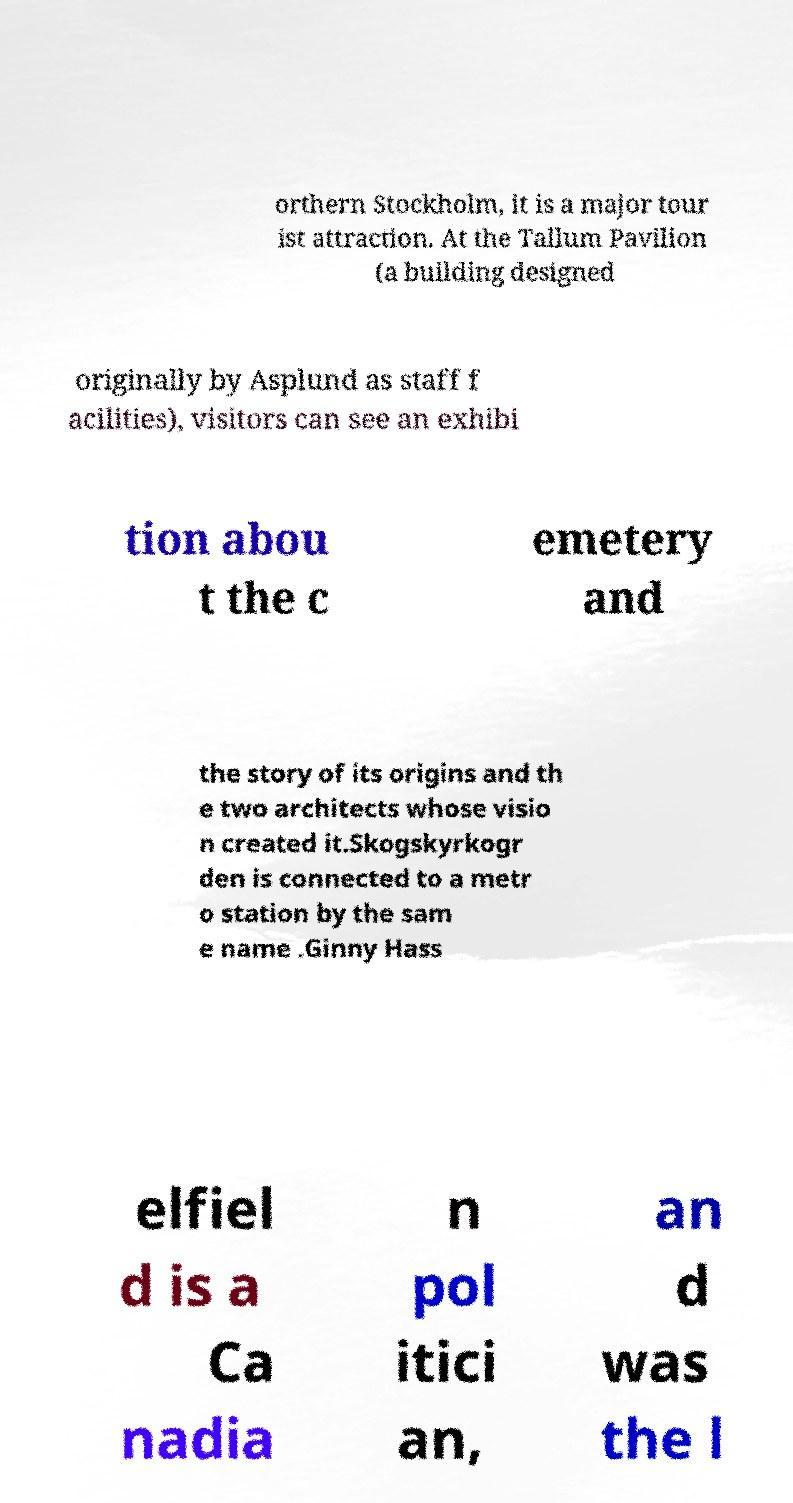For documentation purposes, I need the text within this image transcribed. Could you provide that? orthern Stockholm, it is a major tour ist attraction. At the Tallum Pavilion (a building designed originally by Asplund as staff f acilities), visitors can see an exhibi tion abou t the c emetery and the story of its origins and th e two architects whose visio n created it.Skogskyrkogr den is connected to a metr o station by the sam e name .Ginny Hass elfiel d is a Ca nadia n pol itici an, an d was the l 